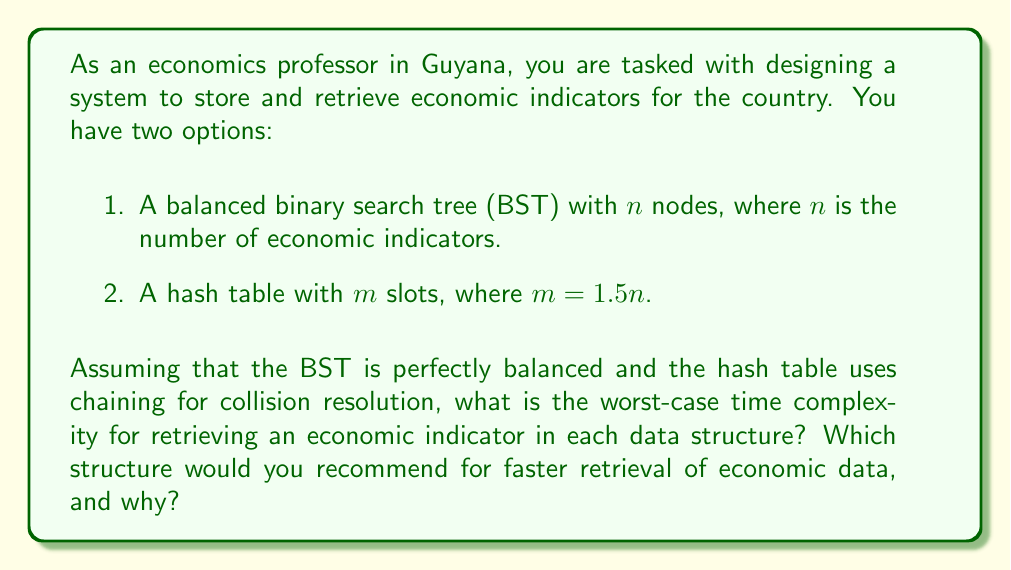Solve this math problem. Let's analyze the worst-case time complexity for retrieving an economic indicator in each data structure:

1. Balanced Binary Search Tree (BST):
   In a perfectly balanced BST with $n$ nodes, the height of the tree is $\log_2(n)$. The worst-case scenario for retrieval occurs when we need to traverse from the root to a leaf node.
   
   Worst-case time complexity: $O(\log n)$

2. Hash Table:
   In a hash table with $m$ slots and $n$ elements, where $m = 1.5n$, we need to consider the worst-case scenario for chaining.
   
   The load factor $\alpha = \frac{n}{m} = \frac{n}{1.5n} = \frac{2}{3}$
   
   In the worst case, all elements could hash to the same slot, creating a chain of length $n$.
   
   Worst-case time complexity: $O(n)$

However, it's important to note that the average-case time complexity for a hash table with a good hash function is $O(1)$, which is generally much better than the worst case.

For the given scenario, the balanced BST would be recommended for the following reasons:

1. Guaranteed $O(\log n)$ worst-case performance for retrieval, which is better than the hash table's worst-case $O(n)$.
2. BSTs maintain order, which can be beneficial for range queries on economic indicators (e.g., finding all indicators within a certain range).
3. BSTs are more memory-efficient, as they don't require extra space for empty slots like hash tables do.

While hash tables can offer better average-case performance, the guaranteed worst-case performance of BSTs makes them a more reliable choice for storing and retrieving economic indicators, especially when consistent performance is crucial for economic analysis and decision-making.
Answer: Worst-case time complexity:
Balanced BST: $O(\log n)$
Hash Table: $O(n)$

Recommended structure: Balanced Binary Search Tree (BST) 